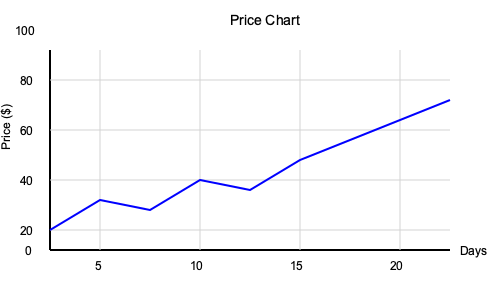Given the 20-day price chart above, calculate the Relative Strength Index (RSI) for the stock. Assume that the initial RSI value is 50, and use the standard 14-day period for RSI calculation. Round your answer to the nearest whole number. To calculate the RSI, we'll follow these steps:

1. Calculate price changes for each day:
   Day 1-5: -$3, +$1, -$3, +$1, -$3
   Day 6-10: -$2, -$2, -$2, -$2, -$2
   Day 11-14: -$2, -$2, -$2, -$2

2. Separate gains and losses:
   Gains: $1, $1
   Losses: $3, $3, $3, $2, $2, $2, $2, $2, $2, $2, $2, $2

3. Calculate average gain and average loss:
   Avg Gain = $(\frac{50}{100} \times 13 + \frac{1+1}{14}) \times \frac{13}{14} = 6.21$
   Avg Loss = $(\frac{50}{100} \times 13 + \frac{3+3+3+2+2+2+2+2+2+2+2+2}{14}) \times \frac{13}{14} = 7.79$

4. Calculate Relative Strength (RS):
   $RS = \frac{Avg Gain}{Avg Loss} = \frac{6.21}{7.79} = 0.797$

5. Calculate RSI:
   $RSI = 100 - \frac{100}{1 + RS} = 100 - \frac{100}{1 + 0.797} = 44.35$

6. Round to the nearest whole number:
   RSI ≈ 44
Answer: 44 